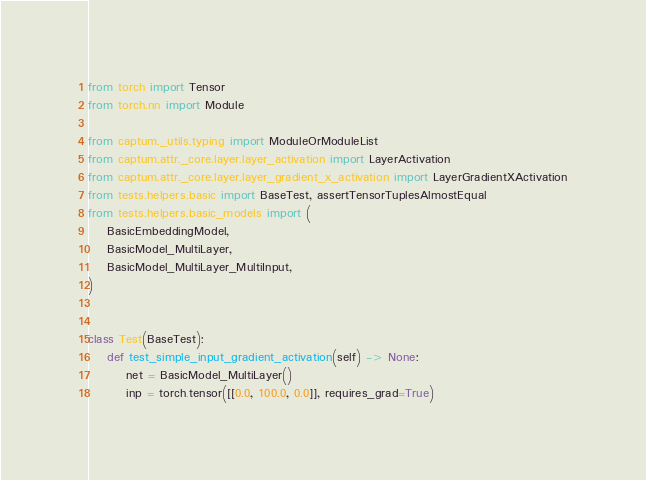<code> <loc_0><loc_0><loc_500><loc_500><_Python_>from torch import Tensor
from torch.nn import Module

from captum._utils.typing import ModuleOrModuleList
from captum.attr._core.layer.layer_activation import LayerActivation
from captum.attr._core.layer.layer_gradient_x_activation import LayerGradientXActivation
from tests.helpers.basic import BaseTest, assertTensorTuplesAlmostEqual
from tests.helpers.basic_models import (
    BasicEmbeddingModel,
    BasicModel_MultiLayer,
    BasicModel_MultiLayer_MultiInput,
)


class Test(BaseTest):
    def test_simple_input_gradient_activation(self) -> None:
        net = BasicModel_MultiLayer()
        inp = torch.tensor([[0.0, 100.0, 0.0]], requires_grad=True)</code> 